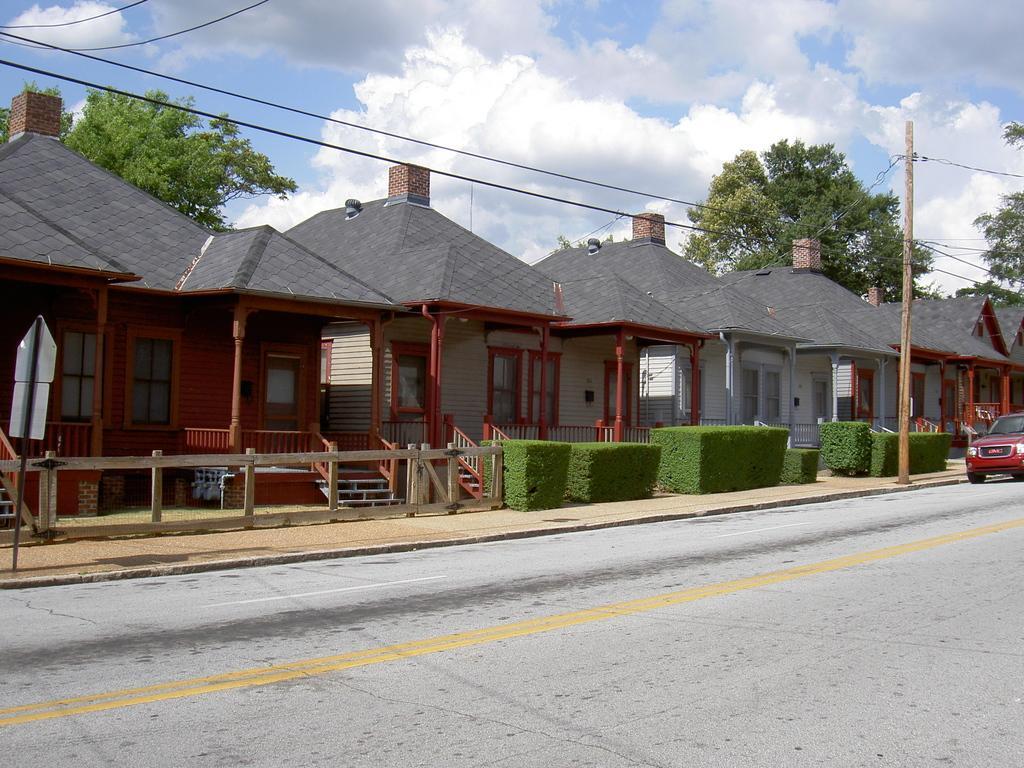Can you describe this image briefly? In this picture we can see few houses, in front of the houses we can find shrubs, few cables, a pole and a car on the road, in the background we can see few trees and clouds. 